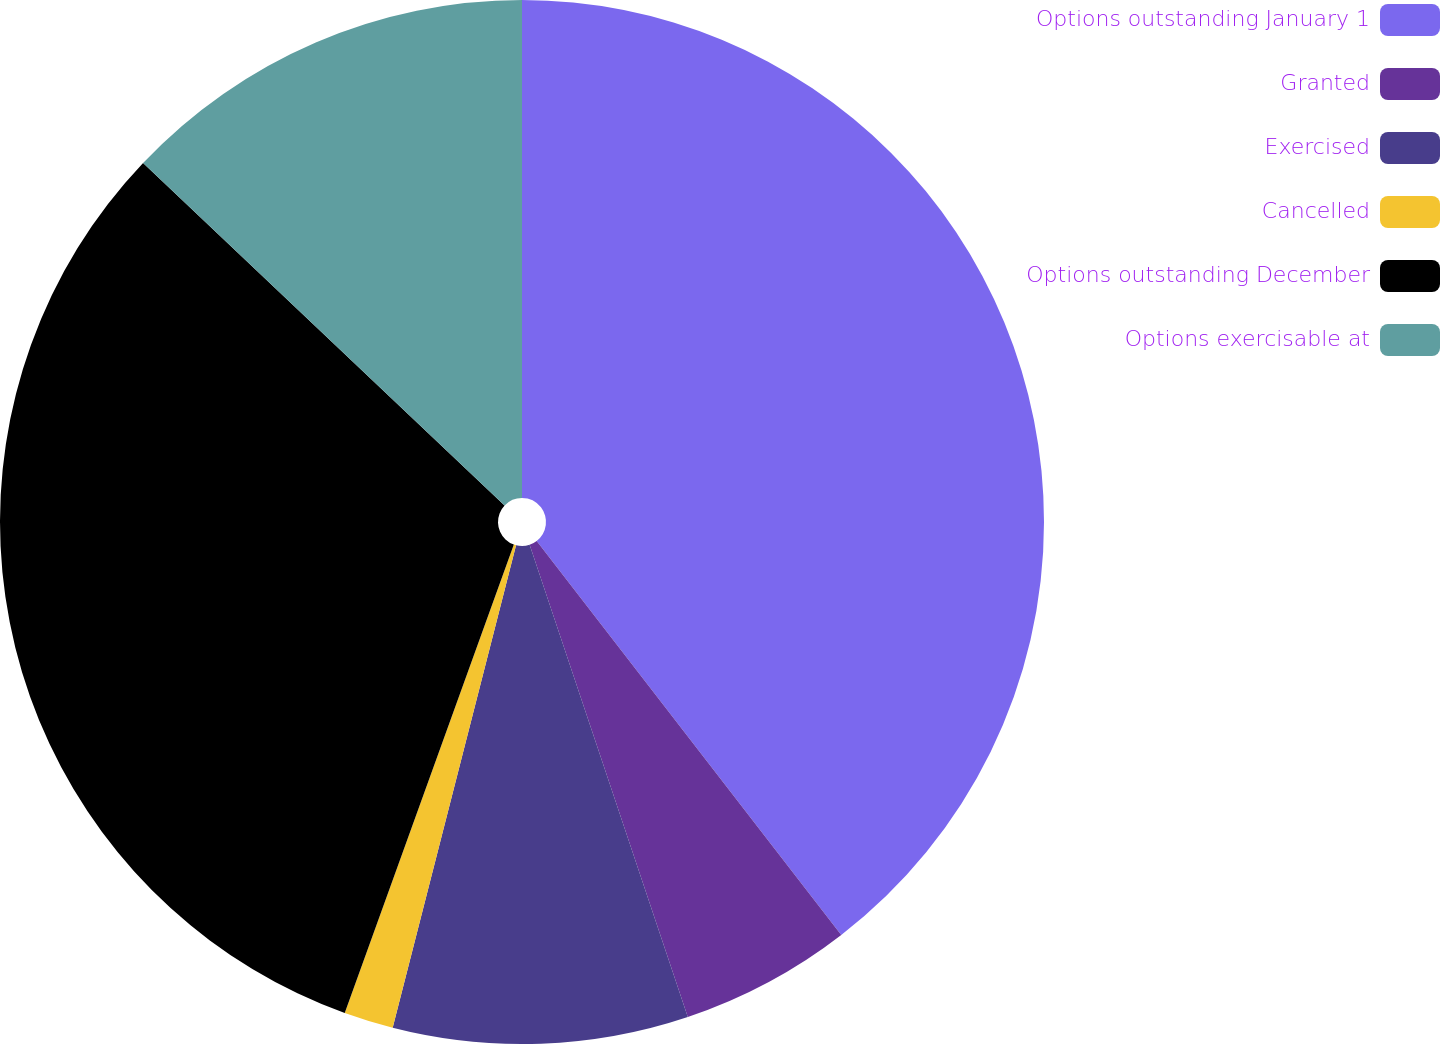Convert chart to OTSL. <chart><loc_0><loc_0><loc_500><loc_500><pie_chart><fcel>Options outstanding January 1<fcel>Granted<fcel>Exercised<fcel>Cancelled<fcel>Options outstanding December<fcel>Options exercisable at<nl><fcel>39.53%<fcel>5.33%<fcel>9.13%<fcel>1.53%<fcel>31.56%<fcel>12.93%<nl></chart> 